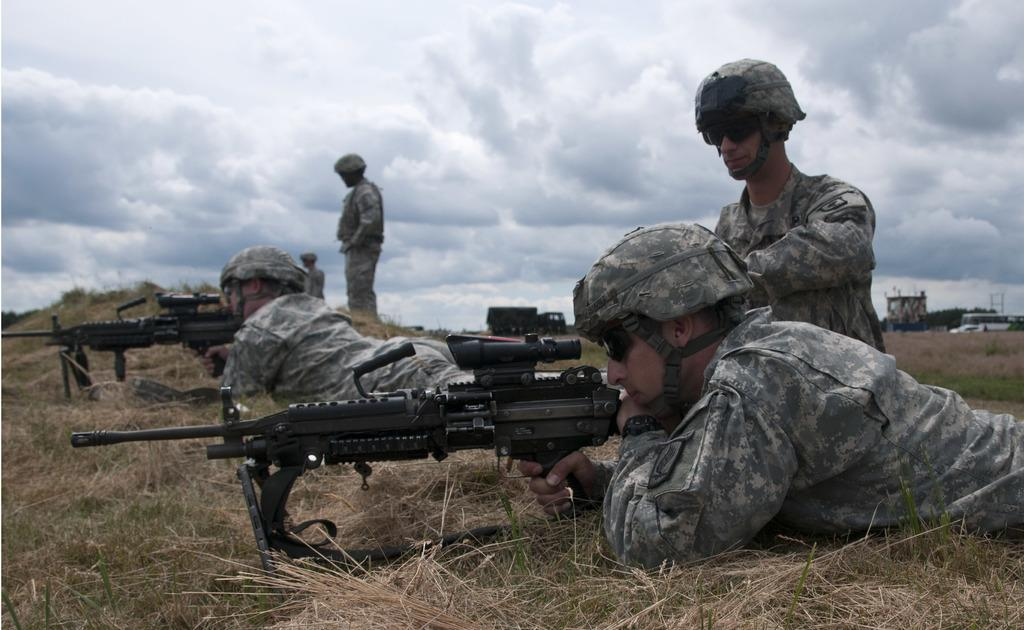What type of people can be seen in the image? There are soldiers in the image. What weapons are visible in the image? There are guns in the image. What type of vegetation is present in the image? There is grass in the image, specifically dry grass. What structures can be seen in the background of the image? There are buildings in the background of the image. What else can be seen in the background of the image? There are vehicles in the background of the image. What is the condition of the sky in the image? The sky is cloudy in the image. What part of the turkey is visible in the image? There is no turkey present in the image. What is the middle of the image used for? The middle of the image is not used for any specific purpose; it simply contains the soldiers and guns. 